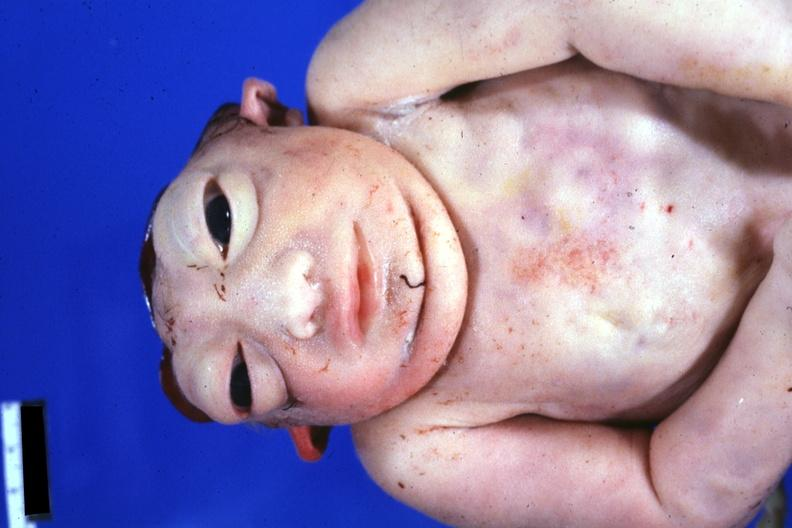what does this image show?
Answer the question using a single word or phrase. View of face and chest anterior 